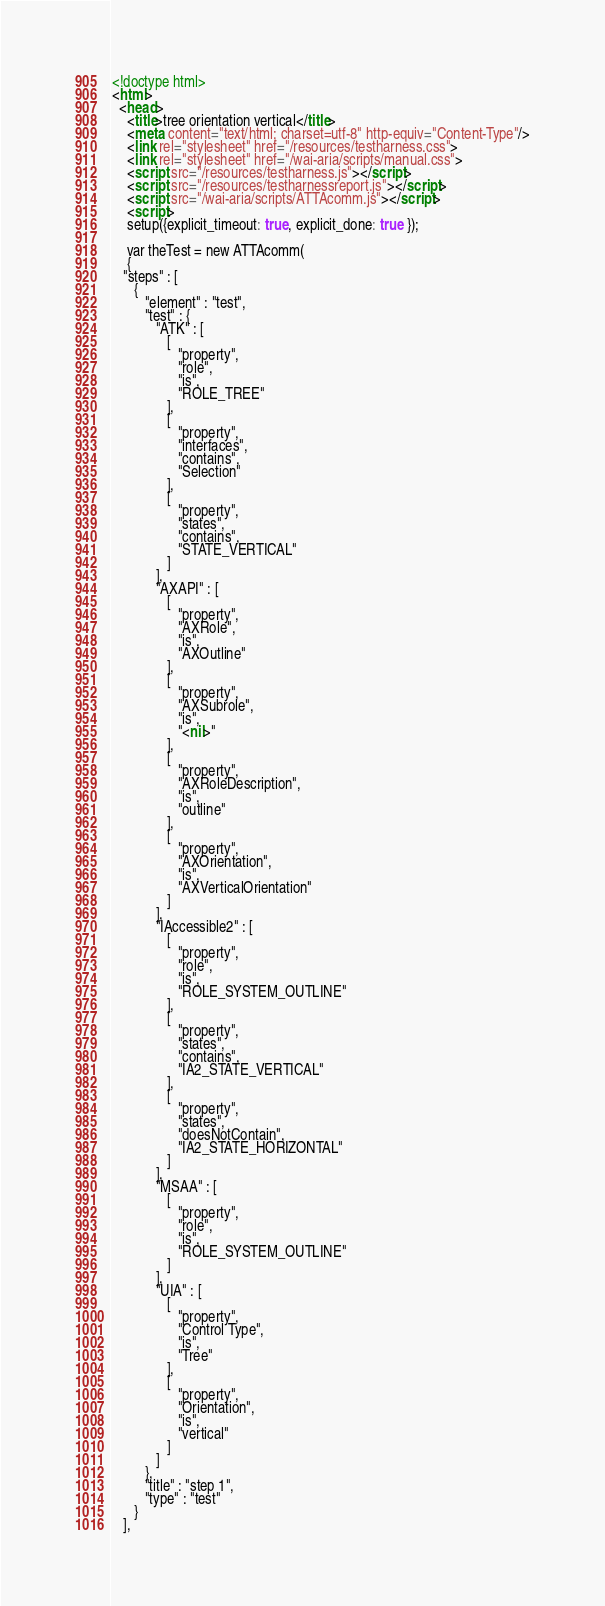Convert code to text. <code><loc_0><loc_0><loc_500><loc_500><_HTML_><!doctype html>
<html>
  <head>
    <title>tree orientation vertical</title>
    <meta content="text/html; charset=utf-8" http-equiv="Content-Type"/>
    <link rel="stylesheet" href="/resources/testharness.css">
    <link rel="stylesheet" href="/wai-aria/scripts/manual.css">
    <script src="/resources/testharness.js"></script>
    <script src="/resources/testharnessreport.js"></script>
    <script src="/wai-aria/scripts/ATTAcomm.js"></script>
    <script>
    setup({explicit_timeout: true, explicit_done: true });

    var theTest = new ATTAcomm(
    {
   "steps" : [
      {
         "element" : "test",
         "test" : {
            "ATK" : [
               [
                  "property",
                  "role",
                  "is",
                  "ROLE_TREE"
               ],
               [
                  "property",
                  "interfaces",
                  "contains",
                  "Selection"
               ],
               [
                  "property",
                  "states",
                  "contains",
                  "STATE_VERTICAL"
               ]
            ],
            "AXAPI" : [
               [
                  "property",
                  "AXRole",
                  "is",
                  "AXOutline"
               ],
               [
                  "property",
                  "AXSubrole",
                  "is",
                  "<nil>"
               ],
               [
                  "property",
                  "AXRoleDescription",
                  "is",
                  "outline"
               ],
               [
                  "property",
                  "AXOrientation",
                  "is",
                  "AXVerticalOrientation"
               ]
            ],
            "IAccessible2" : [
               [
                  "property",
                  "role",
                  "is",
                  "ROLE_SYSTEM_OUTLINE"
               ],
               [
                  "property",
                  "states",
                  "contains",
                  "IA2_STATE_VERTICAL"
               ],
               [
                  "property",
                  "states",
                  "doesNotContain",
                  "IA2_STATE_HORIZONTAL"
               ]
            ],
            "MSAA" : [
               [
                  "property",
                  "role",
                  "is",
                  "ROLE_SYSTEM_OUTLINE"
               ]
            ],
            "UIA" : [
               [
                  "property",
                  "Control Type",
                  "is",
                  "Tree"
               ],
               [
                  "property",
                  "Orientation",
                  "is",
                  "vertical"
               ]
            ]
         },
         "title" : "step 1",
         "type" : "test"
      }
   ],</code> 